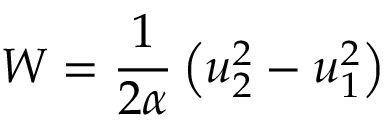Convert formula to latex. <formula><loc_0><loc_0><loc_500><loc_500>W = \frac { 1 } { 2 \alpha } \left ( u _ { 2 } ^ { 2 } - u _ { 1 } ^ { 2 } \right )</formula> 